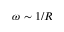<formula> <loc_0><loc_0><loc_500><loc_500>\omega \sim 1 / R</formula> 